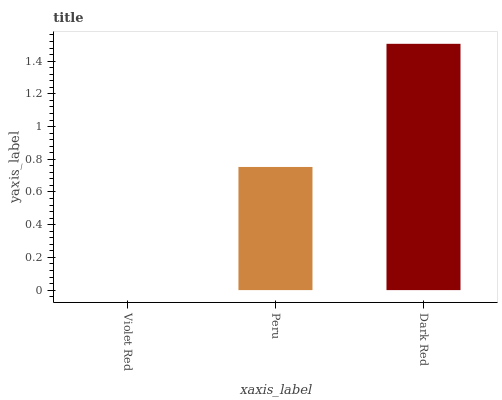Is Violet Red the minimum?
Answer yes or no. Yes. Is Dark Red the maximum?
Answer yes or no. Yes. Is Peru the minimum?
Answer yes or no. No. Is Peru the maximum?
Answer yes or no. No. Is Peru greater than Violet Red?
Answer yes or no. Yes. Is Violet Red less than Peru?
Answer yes or no. Yes. Is Violet Red greater than Peru?
Answer yes or no. No. Is Peru less than Violet Red?
Answer yes or no. No. Is Peru the high median?
Answer yes or no. Yes. Is Peru the low median?
Answer yes or no. Yes. Is Dark Red the high median?
Answer yes or no. No. Is Violet Red the low median?
Answer yes or no. No. 